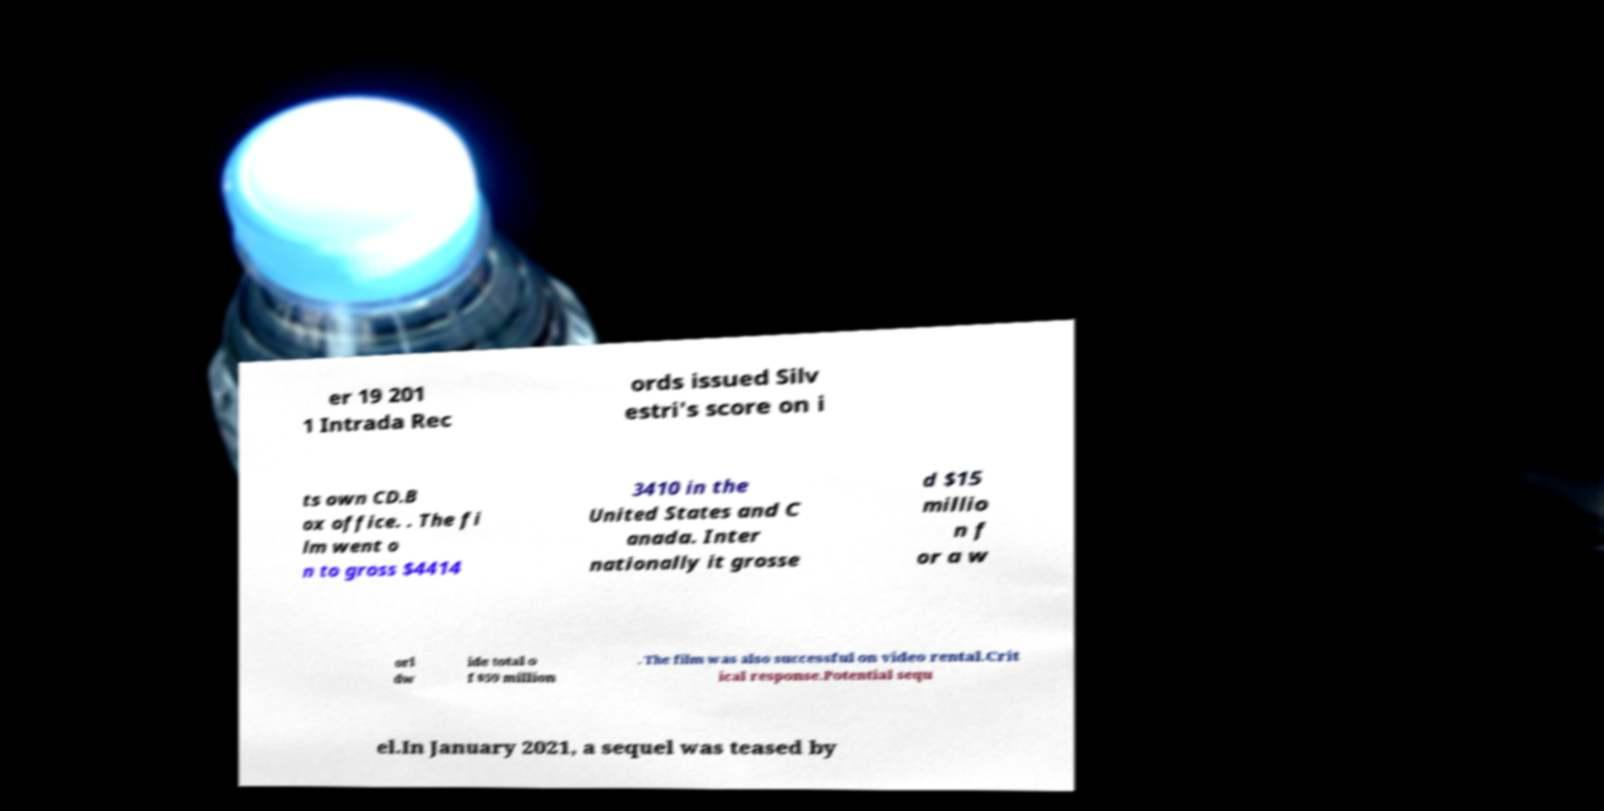Could you assist in decoding the text presented in this image and type it out clearly? er 19 201 1 Intrada Rec ords issued Silv estri's score on i ts own CD.B ox office. . The fi lm went o n to gross $4414 3410 in the United States and C anada. Inter nationally it grosse d $15 millio n f or a w orl dw ide total o f $59 million . The film was also successful on video rental.Crit ical response.Potential sequ el.In January 2021, a sequel was teased by 